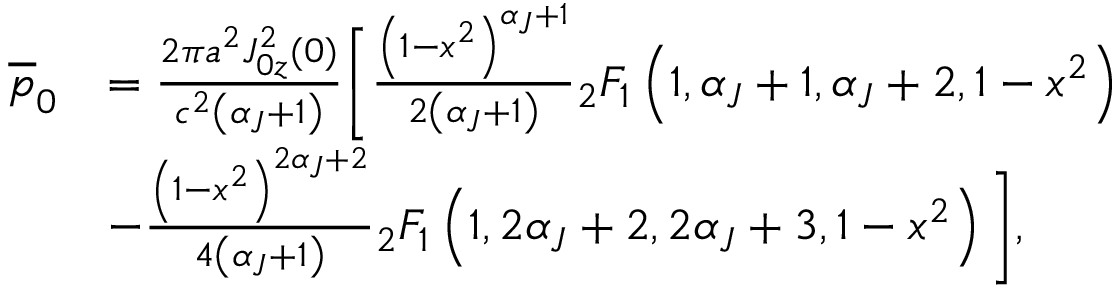<formula> <loc_0><loc_0><loc_500><loc_500>\begin{array} { r l } { \overline { p } _ { 0 } } & { = \frac { 2 \pi a ^ { 2 } J _ { 0 z } ^ { 2 } ( 0 ) } { c ^ { 2 } \left ( \alpha _ { J } + 1 \right ) } \left [ \frac { \left ( 1 - x ^ { 2 } \right ) ^ { \alpha _ { J } + 1 } } { 2 \left ( \alpha _ { J } + 1 \right ) } { _ { 2 } } F _ { 1 } \left ( 1 , \alpha _ { J } + 1 , \alpha _ { J } + 2 , 1 - x ^ { 2 } \right ) } \\ & { - \frac { \left ( 1 - x ^ { 2 } \right ) ^ { 2 \alpha _ { J } + 2 } } { 4 \left ( \alpha _ { J } + 1 \right ) } { _ { 2 } } F _ { 1 } \left ( 1 , 2 \alpha _ { J } + 2 , 2 \alpha _ { J } + 3 , 1 - x ^ { 2 } \right ) \right ] , } \end{array}</formula> 